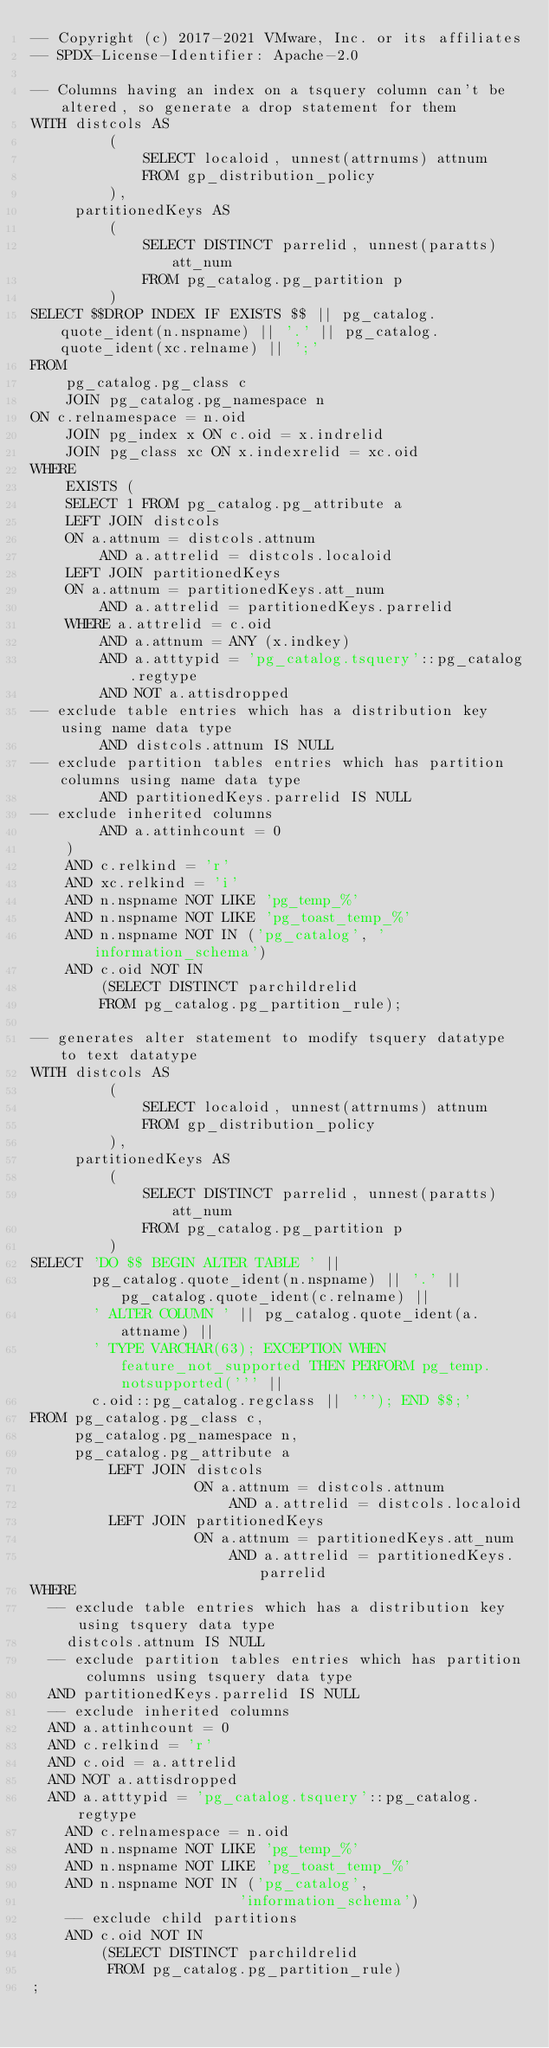<code> <loc_0><loc_0><loc_500><loc_500><_SQL_>-- Copyright (c) 2017-2021 VMware, Inc. or its affiliates
-- SPDX-License-Identifier: Apache-2.0

-- Columns having an index on a tsquery column can't be altered, so generate a drop statement for them
WITH distcols AS
         (
             SELECT localoid, unnest(attrnums) attnum
             FROM gp_distribution_policy
         ),
     partitionedKeys AS
         (
             SELECT DISTINCT parrelid, unnest(paratts) att_num
             FROM pg_catalog.pg_partition p
         )
SELECT $$DROP INDEX IF EXISTS $$ || pg_catalog.quote_ident(n.nspname) || '.' || pg_catalog.quote_ident(xc.relname) || ';'
FROM
    pg_catalog.pg_class c
    JOIN pg_catalog.pg_namespace n
ON c.relnamespace = n.oid
    JOIN pg_index x ON c.oid = x.indrelid
    JOIN pg_class xc ON x.indexrelid = xc.oid
WHERE
    EXISTS (
    SELECT 1 FROM pg_catalog.pg_attribute a
    LEFT JOIN distcols
    ON a.attnum = distcols.attnum
        AND a.attrelid = distcols.localoid
    LEFT JOIN partitionedKeys
    ON a.attnum = partitionedKeys.att_num
        AND a.attrelid = partitionedKeys.parrelid
    WHERE a.attrelid = c.oid
        AND a.attnum = ANY (x.indkey)
        AND a.atttypid = 'pg_catalog.tsquery'::pg_catalog.regtype
        AND NOT a.attisdropped
-- exclude table entries which has a distribution key using name data type
        AND distcols.attnum IS NULL
-- exclude partition tables entries which has partition columns using name data type
        AND partitionedKeys.parrelid IS NULL
-- exclude inherited columns
        AND a.attinhcount = 0
    )
    AND c.relkind = 'r'
    AND xc.relkind = 'i'
    AND n.nspname NOT LIKE 'pg_temp_%'
    AND n.nspname NOT LIKE 'pg_toast_temp_%'
    AND n.nspname NOT IN ('pg_catalog', 'information_schema')
    AND c.oid NOT IN
        (SELECT DISTINCT parchildrelid
        FROM pg_catalog.pg_partition_rule);

-- generates alter statement to modify tsquery datatype to text datatype
WITH distcols AS
         (
             SELECT localoid, unnest(attrnums) attnum
             FROM gp_distribution_policy
         ),
     partitionedKeys AS
         (
             SELECT DISTINCT parrelid, unnest(paratts) att_num
             FROM pg_catalog.pg_partition p
         )
SELECT 'DO $$ BEGIN ALTER TABLE ' ||
       pg_catalog.quote_ident(n.nspname) || '.' || pg_catalog.quote_ident(c.relname) ||
       ' ALTER COLUMN ' || pg_catalog.quote_ident(a.attname) ||
       ' TYPE VARCHAR(63); EXCEPTION WHEN feature_not_supported THEN PERFORM pg_temp.notsupported(''' ||
       c.oid::pg_catalog.regclass || '''); END $$;'
FROM pg_catalog.pg_class c,
     pg_catalog.pg_namespace n,
     pg_catalog.pg_attribute a
         LEFT JOIN distcols
                   ON a.attnum = distcols.attnum
                       AND a.attrelid = distcols.localoid
         LEFT JOIN partitionedKeys
                   ON a.attnum = partitionedKeys.att_num
                       AND a.attrelid = partitionedKeys.parrelid
WHERE
  -- exclude table entries which has a distribution key using tsquery data type
    distcols.attnum IS NULL
  -- exclude partition tables entries which has partition columns using tsquery data type
  AND partitionedKeys.parrelid IS NULL
  -- exclude inherited columns
  AND a.attinhcount = 0
  AND c.relkind = 'r'
  AND c.oid = a.attrelid
  AND NOT a.attisdropped
  AND a.atttypid = 'pg_catalog.tsquery'::pg_catalog.regtype
    AND c.relnamespace = n.oid
    AND n.nspname NOT LIKE 'pg_temp_%'
    AND n.nspname NOT LIKE 'pg_toast_temp_%'
    AND n.nspname NOT IN ('pg_catalog',
                        'information_schema')
    -- exclude child partitions
    AND c.oid NOT IN
        (SELECT DISTINCT parchildrelid
         FROM pg_catalog.pg_partition_rule)
;
</code> 